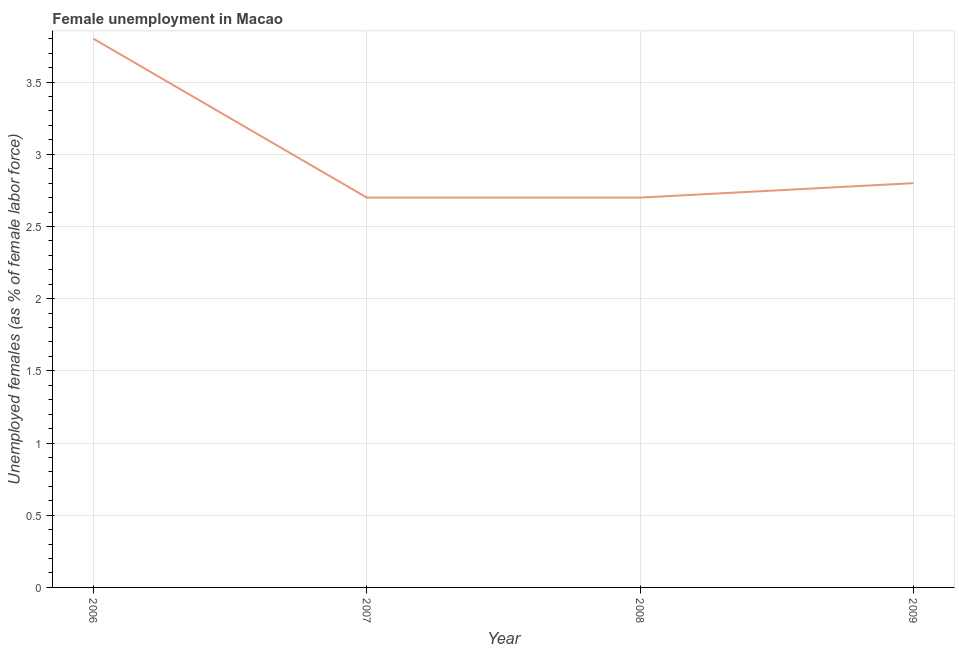What is the unemployed females population in 2008?
Give a very brief answer. 2.7. Across all years, what is the maximum unemployed females population?
Your response must be concise. 3.8. Across all years, what is the minimum unemployed females population?
Provide a succinct answer. 2.7. What is the sum of the unemployed females population?
Provide a succinct answer. 12. What is the difference between the unemployed females population in 2008 and 2009?
Your answer should be very brief. -0.1. What is the average unemployed females population per year?
Your answer should be compact. 3. What is the median unemployed females population?
Your answer should be compact. 2.75. What is the ratio of the unemployed females population in 2007 to that in 2009?
Offer a very short reply. 0.96. Is the unemployed females population in 2007 less than that in 2008?
Keep it short and to the point. No. Is the difference between the unemployed females population in 2006 and 2009 greater than the difference between any two years?
Provide a short and direct response. No. What is the difference between the highest and the second highest unemployed females population?
Make the answer very short. 1. What is the difference between the highest and the lowest unemployed females population?
Make the answer very short. 1.1. In how many years, is the unemployed females population greater than the average unemployed females population taken over all years?
Provide a short and direct response. 1. How many years are there in the graph?
Offer a terse response. 4. Are the values on the major ticks of Y-axis written in scientific E-notation?
Ensure brevity in your answer.  No. What is the title of the graph?
Offer a very short reply. Female unemployment in Macao. What is the label or title of the X-axis?
Your response must be concise. Year. What is the label or title of the Y-axis?
Provide a succinct answer. Unemployed females (as % of female labor force). What is the Unemployed females (as % of female labor force) in 2006?
Provide a succinct answer. 3.8. What is the Unemployed females (as % of female labor force) in 2007?
Provide a short and direct response. 2.7. What is the Unemployed females (as % of female labor force) of 2008?
Your answer should be very brief. 2.7. What is the Unemployed females (as % of female labor force) of 2009?
Your answer should be very brief. 2.8. What is the difference between the Unemployed females (as % of female labor force) in 2007 and 2008?
Offer a terse response. 0. What is the difference between the Unemployed females (as % of female labor force) in 2007 and 2009?
Make the answer very short. -0.1. What is the ratio of the Unemployed females (as % of female labor force) in 2006 to that in 2007?
Ensure brevity in your answer.  1.41. What is the ratio of the Unemployed females (as % of female labor force) in 2006 to that in 2008?
Your answer should be compact. 1.41. What is the ratio of the Unemployed females (as % of female labor force) in 2006 to that in 2009?
Ensure brevity in your answer.  1.36. What is the ratio of the Unemployed females (as % of female labor force) in 2007 to that in 2009?
Offer a very short reply. 0.96. 